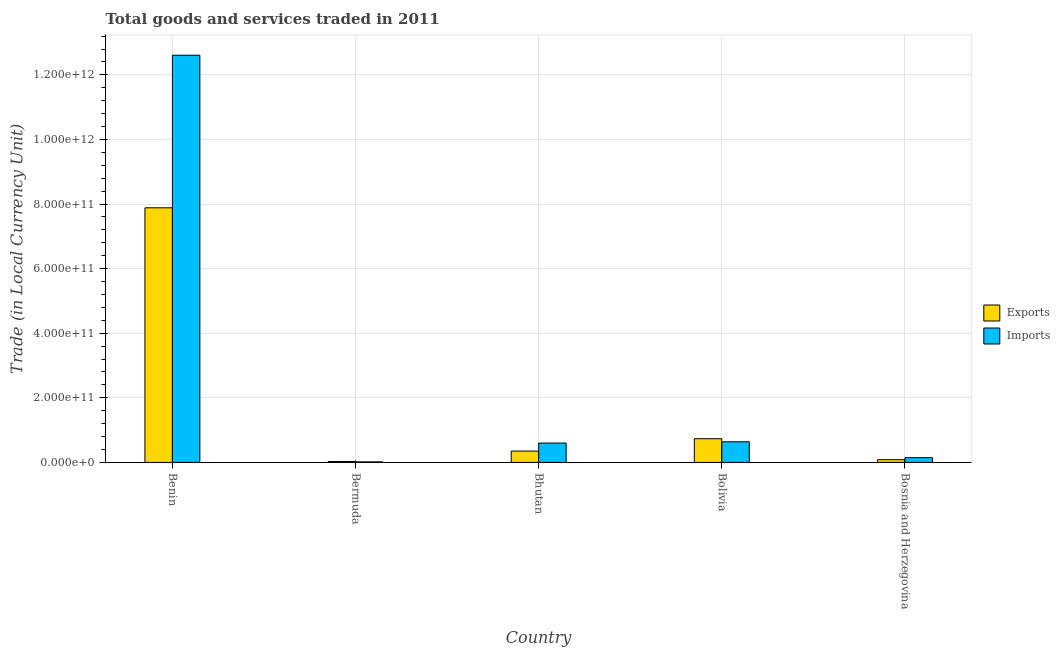How many different coloured bars are there?
Make the answer very short. 2. How many groups of bars are there?
Offer a very short reply. 5. Are the number of bars per tick equal to the number of legend labels?
Offer a terse response. Yes. What is the label of the 3rd group of bars from the left?
Your answer should be very brief. Bhutan. In how many cases, is the number of bars for a given country not equal to the number of legend labels?
Offer a very short reply. 0. What is the imports of goods and services in Bosnia and Herzegovina?
Give a very brief answer. 1.46e+1. Across all countries, what is the maximum export of goods and services?
Your response must be concise. 7.88e+11. Across all countries, what is the minimum export of goods and services?
Provide a short and direct response. 2.64e+09. In which country was the imports of goods and services maximum?
Keep it short and to the point. Benin. In which country was the export of goods and services minimum?
Offer a very short reply. Bermuda. What is the total imports of goods and services in the graph?
Your answer should be very brief. 1.40e+12. What is the difference between the imports of goods and services in Benin and that in Bolivia?
Your response must be concise. 1.20e+12. What is the difference between the export of goods and services in Bermuda and the imports of goods and services in Bhutan?
Offer a terse response. -5.72e+1. What is the average imports of goods and services per country?
Give a very brief answer. 2.80e+11. What is the difference between the export of goods and services and imports of goods and services in Bosnia and Herzegovina?
Your response must be concise. -6.23e+09. What is the ratio of the imports of goods and services in Benin to that in Bolivia?
Keep it short and to the point. 19.76. Is the imports of goods and services in Bolivia less than that in Bosnia and Herzegovina?
Make the answer very short. No. Is the difference between the export of goods and services in Benin and Bhutan greater than the difference between the imports of goods and services in Benin and Bhutan?
Keep it short and to the point. No. What is the difference between the highest and the second highest imports of goods and services?
Make the answer very short. 1.20e+12. What is the difference between the highest and the lowest export of goods and services?
Offer a terse response. 7.86e+11. Is the sum of the export of goods and services in Benin and Bosnia and Herzegovina greater than the maximum imports of goods and services across all countries?
Ensure brevity in your answer.  No. What does the 2nd bar from the left in Bermuda represents?
Offer a very short reply. Imports. What does the 2nd bar from the right in Bhutan represents?
Offer a very short reply. Exports. How many bars are there?
Keep it short and to the point. 10. Are all the bars in the graph horizontal?
Give a very brief answer. No. What is the difference between two consecutive major ticks on the Y-axis?
Your answer should be compact. 2.00e+11. Are the values on the major ticks of Y-axis written in scientific E-notation?
Provide a succinct answer. Yes. Does the graph contain any zero values?
Provide a succinct answer. No. Does the graph contain grids?
Your answer should be compact. Yes. Where does the legend appear in the graph?
Your answer should be compact. Center right. How many legend labels are there?
Provide a succinct answer. 2. How are the legend labels stacked?
Your response must be concise. Vertical. What is the title of the graph?
Your answer should be compact. Total goods and services traded in 2011. Does "Age 65(male)" appear as one of the legend labels in the graph?
Your response must be concise. No. What is the label or title of the X-axis?
Give a very brief answer. Country. What is the label or title of the Y-axis?
Provide a succinct answer. Trade (in Local Currency Unit). What is the Trade (in Local Currency Unit) in Exports in Benin?
Ensure brevity in your answer.  7.88e+11. What is the Trade (in Local Currency Unit) in Imports in Benin?
Offer a very short reply. 1.26e+12. What is the Trade (in Local Currency Unit) of Exports in Bermuda?
Ensure brevity in your answer.  2.64e+09. What is the Trade (in Local Currency Unit) in Imports in Bermuda?
Give a very brief answer. 1.60e+09. What is the Trade (in Local Currency Unit) in Exports in Bhutan?
Your response must be concise. 3.50e+1. What is the Trade (in Local Currency Unit) in Imports in Bhutan?
Your answer should be compact. 5.99e+1. What is the Trade (in Local Currency Unit) of Exports in Bolivia?
Ensure brevity in your answer.  7.33e+1. What is the Trade (in Local Currency Unit) in Imports in Bolivia?
Ensure brevity in your answer.  6.38e+1. What is the Trade (in Local Currency Unit) of Exports in Bosnia and Herzegovina?
Provide a succinct answer. 8.40e+09. What is the Trade (in Local Currency Unit) of Imports in Bosnia and Herzegovina?
Ensure brevity in your answer.  1.46e+1. Across all countries, what is the maximum Trade (in Local Currency Unit) of Exports?
Your answer should be compact. 7.88e+11. Across all countries, what is the maximum Trade (in Local Currency Unit) of Imports?
Your answer should be very brief. 1.26e+12. Across all countries, what is the minimum Trade (in Local Currency Unit) of Exports?
Offer a very short reply. 2.64e+09. Across all countries, what is the minimum Trade (in Local Currency Unit) in Imports?
Make the answer very short. 1.60e+09. What is the total Trade (in Local Currency Unit) in Exports in the graph?
Your answer should be very brief. 9.08e+11. What is the total Trade (in Local Currency Unit) in Imports in the graph?
Offer a very short reply. 1.40e+12. What is the difference between the Trade (in Local Currency Unit) of Exports in Benin and that in Bermuda?
Keep it short and to the point. 7.86e+11. What is the difference between the Trade (in Local Currency Unit) in Imports in Benin and that in Bermuda?
Your response must be concise. 1.26e+12. What is the difference between the Trade (in Local Currency Unit) of Exports in Benin and that in Bhutan?
Your answer should be very brief. 7.53e+11. What is the difference between the Trade (in Local Currency Unit) of Imports in Benin and that in Bhutan?
Provide a short and direct response. 1.20e+12. What is the difference between the Trade (in Local Currency Unit) in Exports in Benin and that in Bolivia?
Offer a terse response. 7.15e+11. What is the difference between the Trade (in Local Currency Unit) of Imports in Benin and that in Bolivia?
Your answer should be compact. 1.20e+12. What is the difference between the Trade (in Local Currency Unit) of Exports in Benin and that in Bosnia and Herzegovina?
Keep it short and to the point. 7.80e+11. What is the difference between the Trade (in Local Currency Unit) in Imports in Benin and that in Bosnia and Herzegovina?
Provide a short and direct response. 1.25e+12. What is the difference between the Trade (in Local Currency Unit) of Exports in Bermuda and that in Bhutan?
Ensure brevity in your answer.  -3.24e+1. What is the difference between the Trade (in Local Currency Unit) of Imports in Bermuda and that in Bhutan?
Give a very brief answer. -5.83e+1. What is the difference between the Trade (in Local Currency Unit) in Exports in Bermuda and that in Bolivia?
Keep it short and to the point. -7.07e+1. What is the difference between the Trade (in Local Currency Unit) of Imports in Bermuda and that in Bolivia?
Your response must be concise. -6.22e+1. What is the difference between the Trade (in Local Currency Unit) of Exports in Bermuda and that in Bosnia and Herzegovina?
Your answer should be compact. -5.76e+09. What is the difference between the Trade (in Local Currency Unit) of Imports in Bermuda and that in Bosnia and Herzegovina?
Provide a succinct answer. -1.30e+1. What is the difference between the Trade (in Local Currency Unit) in Exports in Bhutan and that in Bolivia?
Provide a short and direct response. -3.83e+1. What is the difference between the Trade (in Local Currency Unit) of Imports in Bhutan and that in Bolivia?
Make the answer very short. -3.94e+09. What is the difference between the Trade (in Local Currency Unit) in Exports in Bhutan and that in Bosnia and Herzegovina?
Provide a succinct answer. 2.66e+1. What is the difference between the Trade (in Local Currency Unit) of Imports in Bhutan and that in Bosnia and Herzegovina?
Make the answer very short. 4.52e+1. What is the difference between the Trade (in Local Currency Unit) in Exports in Bolivia and that in Bosnia and Herzegovina?
Give a very brief answer. 6.49e+1. What is the difference between the Trade (in Local Currency Unit) in Imports in Bolivia and that in Bosnia and Herzegovina?
Provide a succinct answer. 4.92e+1. What is the difference between the Trade (in Local Currency Unit) of Exports in Benin and the Trade (in Local Currency Unit) of Imports in Bermuda?
Give a very brief answer. 7.87e+11. What is the difference between the Trade (in Local Currency Unit) in Exports in Benin and the Trade (in Local Currency Unit) in Imports in Bhutan?
Your answer should be compact. 7.29e+11. What is the difference between the Trade (in Local Currency Unit) of Exports in Benin and the Trade (in Local Currency Unit) of Imports in Bolivia?
Provide a succinct answer. 7.25e+11. What is the difference between the Trade (in Local Currency Unit) of Exports in Benin and the Trade (in Local Currency Unit) of Imports in Bosnia and Herzegovina?
Your response must be concise. 7.74e+11. What is the difference between the Trade (in Local Currency Unit) of Exports in Bermuda and the Trade (in Local Currency Unit) of Imports in Bhutan?
Ensure brevity in your answer.  -5.72e+1. What is the difference between the Trade (in Local Currency Unit) in Exports in Bermuda and the Trade (in Local Currency Unit) in Imports in Bolivia?
Give a very brief answer. -6.12e+1. What is the difference between the Trade (in Local Currency Unit) in Exports in Bermuda and the Trade (in Local Currency Unit) in Imports in Bosnia and Herzegovina?
Provide a short and direct response. -1.20e+1. What is the difference between the Trade (in Local Currency Unit) in Exports in Bhutan and the Trade (in Local Currency Unit) in Imports in Bolivia?
Make the answer very short. -2.88e+1. What is the difference between the Trade (in Local Currency Unit) in Exports in Bhutan and the Trade (in Local Currency Unit) in Imports in Bosnia and Herzegovina?
Offer a very short reply. 2.04e+1. What is the difference between the Trade (in Local Currency Unit) of Exports in Bolivia and the Trade (in Local Currency Unit) of Imports in Bosnia and Herzegovina?
Provide a succinct answer. 5.87e+1. What is the average Trade (in Local Currency Unit) of Exports per country?
Provide a short and direct response. 1.82e+11. What is the average Trade (in Local Currency Unit) in Imports per country?
Provide a short and direct response. 2.80e+11. What is the difference between the Trade (in Local Currency Unit) of Exports and Trade (in Local Currency Unit) of Imports in Benin?
Keep it short and to the point. -4.72e+11. What is the difference between the Trade (in Local Currency Unit) of Exports and Trade (in Local Currency Unit) of Imports in Bermuda?
Provide a short and direct response. 1.04e+09. What is the difference between the Trade (in Local Currency Unit) of Exports and Trade (in Local Currency Unit) of Imports in Bhutan?
Your answer should be very brief. -2.49e+1. What is the difference between the Trade (in Local Currency Unit) of Exports and Trade (in Local Currency Unit) of Imports in Bolivia?
Give a very brief answer. 9.48e+09. What is the difference between the Trade (in Local Currency Unit) in Exports and Trade (in Local Currency Unit) in Imports in Bosnia and Herzegovina?
Provide a succinct answer. -6.23e+09. What is the ratio of the Trade (in Local Currency Unit) in Exports in Benin to that in Bermuda?
Provide a succinct answer. 298.16. What is the ratio of the Trade (in Local Currency Unit) of Imports in Benin to that in Bermuda?
Offer a very short reply. 787.57. What is the ratio of the Trade (in Local Currency Unit) of Exports in Benin to that in Bhutan?
Offer a very short reply. 22.52. What is the ratio of the Trade (in Local Currency Unit) of Imports in Benin to that in Bhutan?
Your answer should be compact. 21.06. What is the ratio of the Trade (in Local Currency Unit) in Exports in Benin to that in Bolivia?
Offer a very short reply. 10.76. What is the ratio of the Trade (in Local Currency Unit) of Imports in Benin to that in Bolivia?
Give a very brief answer. 19.76. What is the ratio of the Trade (in Local Currency Unit) of Exports in Benin to that in Bosnia and Herzegovina?
Provide a short and direct response. 93.82. What is the ratio of the Trade (in Local Currency Unit) in Imports in Benin to that in Bosnia and Herzegovina?
Give a very brief answer. 86.14. What is the ratio of the Trade (in Local Currency Unit) of Exports in Bermuda to that in Bhutan?
Your answer should be very brief. 0.08. What is the ratio of the Trade (in Local Currency Unit) in Imports in Bermuda to that in Bhutan?
Give a very brief answer. 0.03. What is the ratio of the Trade (in Local Currency Unit) of Exports in Bermuda to that in Bolivia?
Your response must be concise. 0.04. What is the ratio of the Trade (in Local Currency Unit) in Imports in Bermuda to that in Bolivia?
Give a very brief answer. 0.03. What is the ratio of the Trade (in Local Currency Unit) of Exports in Bermuda to that in Bosnia and Herzegovina?
Give a very brief answer. 0.31. What is the ratio of the Trade (in Local Currency Unit) of Imports in Bermuda to that in Bosnia and Herzegovina?
Give a very brief answer. 0.11. What is the ratio of the Trade (in Local Currency Unit) of Exports in Bhutan to that in Bolivia?
Provide a succinct answer. 0.48. What is the ratio of the Trade (in Local Currency Unit) in Imports in Bhutan to that in Bolivia?
Give a very brief answer. 0.94. What is the ratio of the Trade (in Local Currency Unit) of Exports in Bhutan to that in Bosnia and Herzegovina?
Your response must be concise. 4.17. What is the ratio of the Trade (in Local Currency Unit) of Imports in Bhutan to that in Bosnia and Herzegovina?
Offer a terse response. 4.09. What is the ratio of the Trade (in Local Currency Unit) in Exports in Bolivia to that in Bosnia and Herzegovina?
Your response must be concise. 8.72. What is the ratio of the Trade (in Local Currency Unit) of Imports in Bolivia to that in Bosnia and Herzegovina?
Make the answer very short. 4.36. What is the difference between the highest and the second highest Trade (in Local Currency Unit) of Exports?
Your answer should be compact. 7.15e+11. What is the difference between the highest and the second highest Trade (in Local Currency Unit) of Imports?
Give a very brief answer. 1.20e+12. What is the difference between the highest and the lowest Trade (in Local Currency Unit) in Exports?
Provide a short and direct response. 7.86e+11. What is the difference between the highest and the lowest Trade (in Local Currency Unit) of Imports?
Offer a terse response. 1.26e+12. 